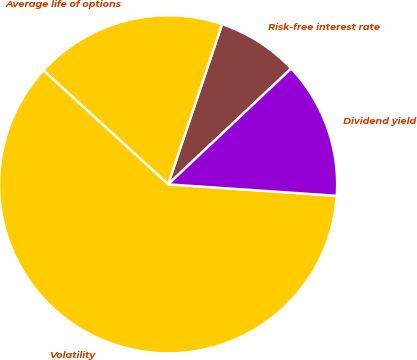<chart> <loc_0><loc_0><loc_500><loc_500><pie_chart><fcel>Risk-free interest rate<fcel>Average life of options<fcel>Volatility<fcel>Dividend yield<nl><fcel>7.81%<fcel>18.39%<fcel>60.71%<fcel>13.1%<nl></chart> 